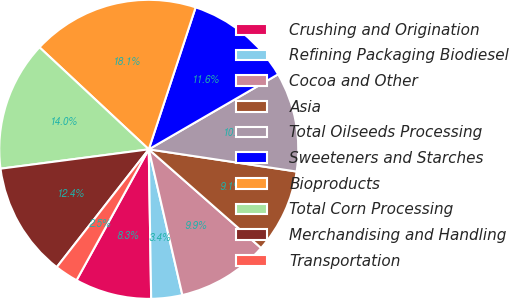<chart> <loc_0><loc_0><loc_500><loc_500><pie_chart><fcel>Crushing and Origination<fcel>Refining Packaging Biodiesel<fcel>Cocoa and Other<fcel>Asia<fcel>Total Oilseeds Processing<fcel>Sweeteners and Starches<fcel>Bioproducts<fcel>Total Corn Processing<fcel>Merchandising and Handling<fcel>Transportation<nl><fcel>8.28%<fcel>3.35%<fcel>9.92%<fcel>9.1%<fcel>10.74%<fcel>11.56%<fcel>18.12%<fcel>14.02%<fcel>12.38%<fcel>2.53%<nl></chart> 